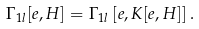<formula> <loc_0><loc_0><loc_500><loc_500>\Gamma _ { 1 l } [ e , H ] = \Gamma _ { 1 l } \left [ e , K [ e , H ] \right ] .</formula> 